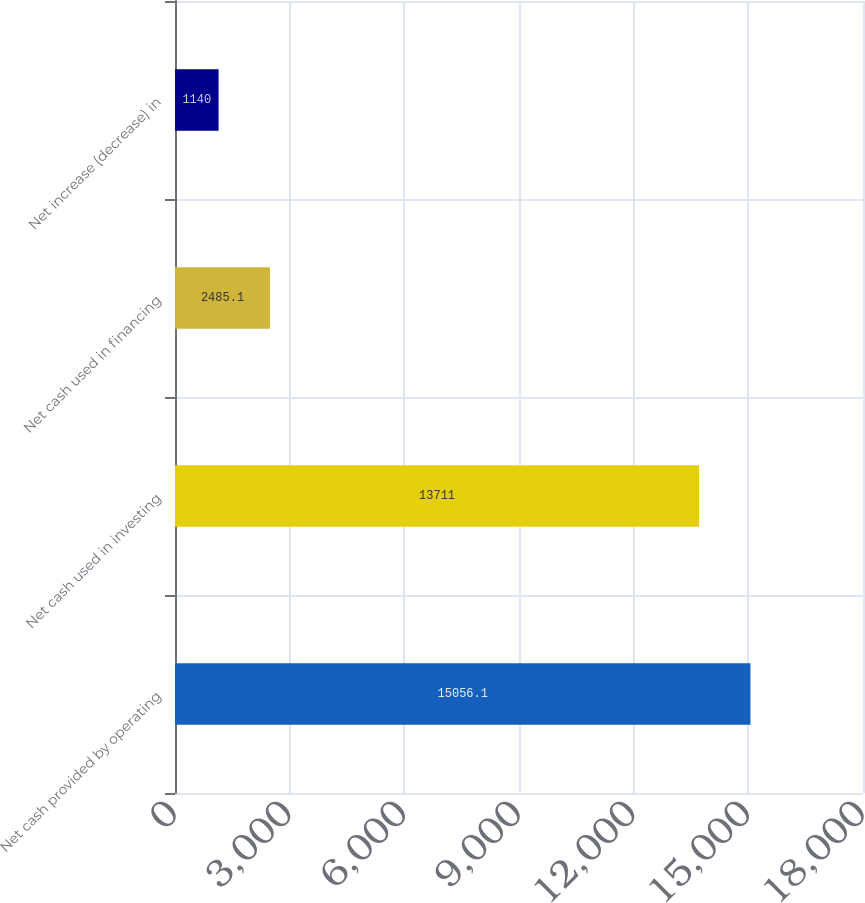Convert chart to OTSL. <chart><loc_0><loc_0><loc_500><loc_500><bar_chart><fcel>Net cash provided by operating<fcel>Net cash used in investing<fcel>Net cash used in financing<fcel>Net increase (decrease) in<nl><fcel>15056.1<fcel>13711<fcel>2485.1<fcel>1140<nl></chart> 